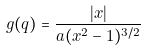Convert formula to latex. <formula><loc_0><loc_0><loc_500><loc_500>g ( q ) = \frac { | x | } { a ( x ^ { 2 } - 1 ) ^ { 3 / 2 } }</formula> 